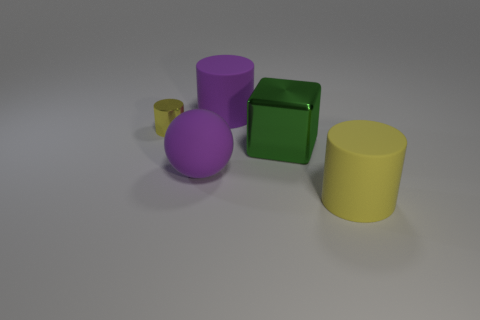Are there any other things that are the same size as the yellow metallic object?
Give a very brief answer. No. What number of things are tiny brown balls or big cylinders right of the metal block?
Your response must be concise. 1. There is a matte cylinder to the left of the rubber thing in front of the purple sphere; what is its color?
Provide a short and direct response. Purple. There is a big rubber cylinder that is behind the sphere; is its color the same as the metallic cylinder?
Your answer should be compact. No. There is a big cylinder left of the big yellow rubber object; what material is it?
Provide a short and direct response. Rubber. What size is the yellow rubber cylinder?
Your answer should be compact. Large. Is the large purple thing that is in front of the tiny yellow cylinder made of the same material as the tiny yellow object?
Your answer should be very brief. No. How many big purple matte cylinders are there?
Provide a short and direct response. 1. What number of objects are shiny cubes or large rubber balls?
Ensure brevity in your answer.  2. There is a yellow cylinder on the left side of the yellow cylinder to the right of the small yellow thing; what number of yellow things are behind it?
Give a very brief answer. 0. 